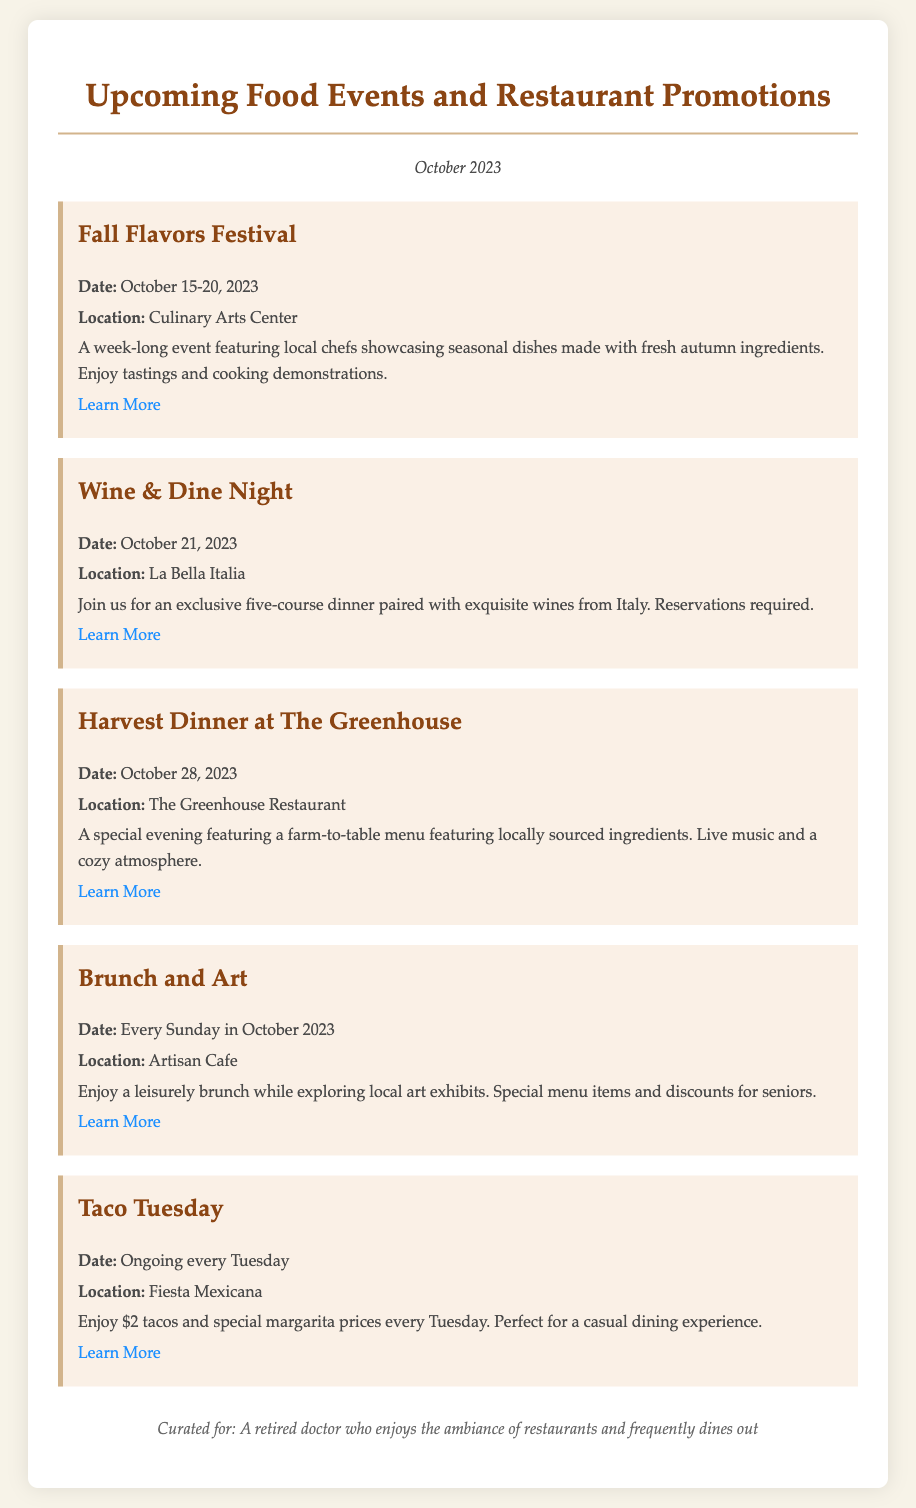What is the date of the Fall Flavors Festival? The date is explicitly stated in the document as October 15-20, 2023.
Answer: October 15-20, 2023 Where is the Wine & Dine Night taking place? The location for this event is mentioned as La Bella Italia in the document.
Answer: La Bella Italia What type of dinner is offered at The Greenhouse on October 28? The specific type of dinner is indicated as a special evening featuring a farm-to-table menu.
Answer: Farm-to-table menu How often does the Brunch and Art event occur? The document specifies that it happens every Sunday in October 2023.
Answer: Every Sunday in October 2023 What is the price of tacos during Taco Tuesday? The document states that tacos are available for $2 during Taco Tuesday.
Answer: $2 tacos What can attendees expect at the Fall Flavors Festival? The document describes the festival as featuring local chefs showcasing seasonal dishes with tastings and cooking demonstrations.
Answer: Seasonal dishes, tastings, cooking demonstrations Which event requires reservations? The document explicitly mentions that reservations are required for the Wine & Dine Night.
Answer: Wine & Dine Night What type of atmosphere is highlighted for the Harvest Dinner? The document describes the atmosphere as cozy during the Harvest Dinner at The Greenhouse.
Answer: Cozy atmosphere 